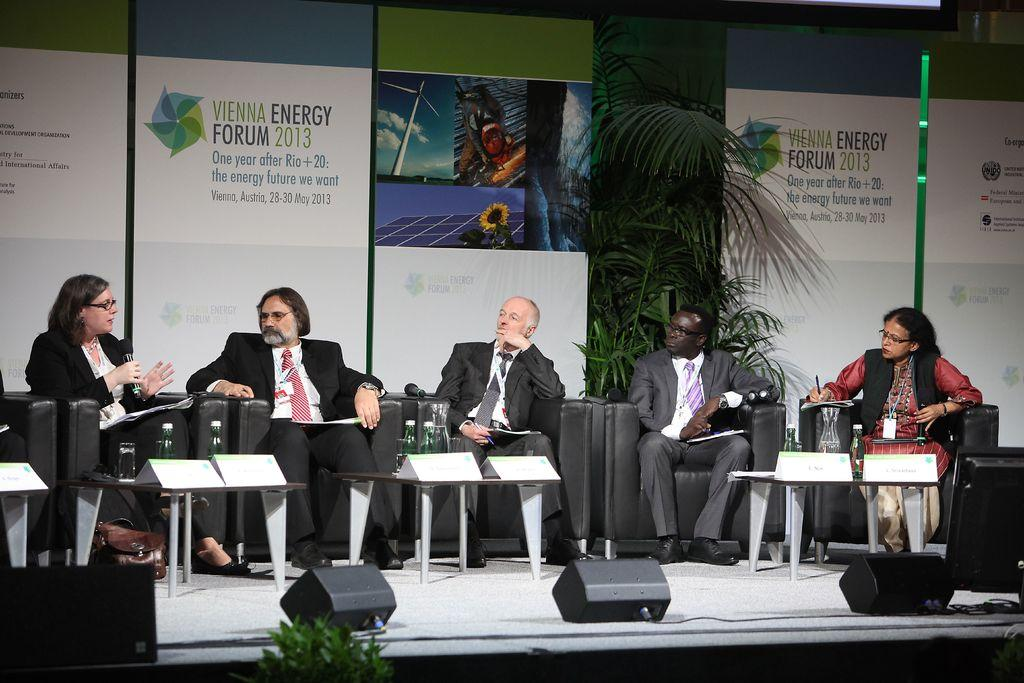What are the people in the image doing? The people in the image are sitting on chairs. Can you describe the woman in the image? The woman in the image is holding a microphone in her hand. What type of trees can be seen on the trail in the image? There is no trail or trees present in the image. What statement is the woman making into the microphone in the image? The image does not show the woman speaking into the microphone, so it is not possible to determine what statement she might be making. 